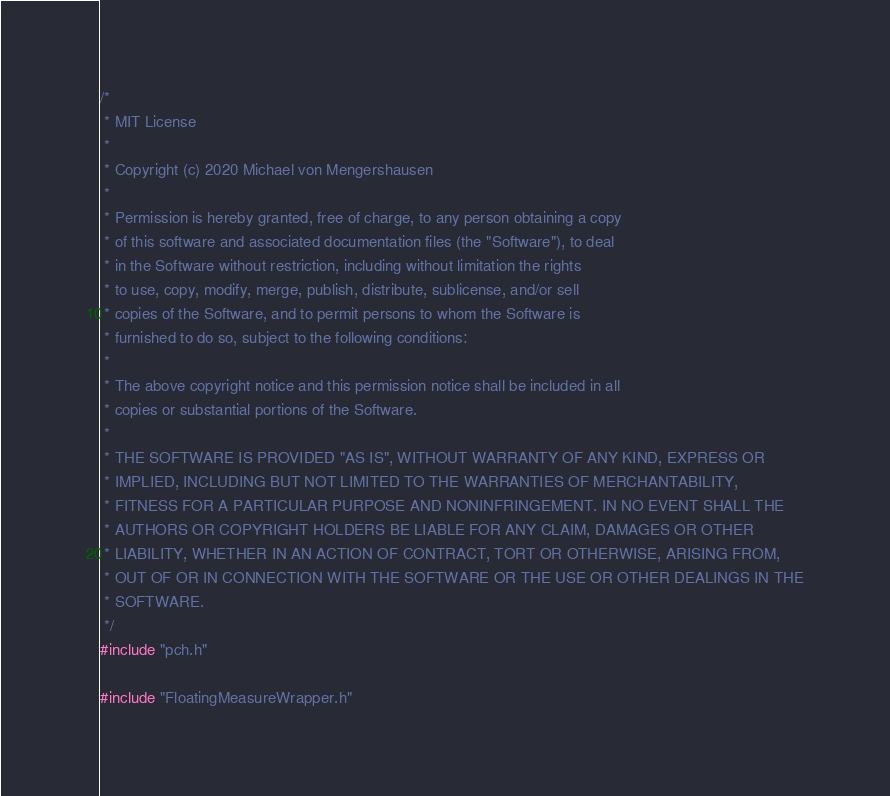Convert code to text. <code><loc_0><loc_0><loc_500><loc_500><_C++_>/*
 * MIT License
 *
 * Copyright (c) 2020 Michael von Mengershausen
 *
 * Permission is hereby granted, free of charge, to any person obtaining a copy
 * of this software and associated documentation files (the "Software"), to deal
 * in the Software without restriction, including without limitation the rights
 * to use, copy, modify, merge, publish, distribute, sublicense, and/or sell
 * copies of the Software, and to permit persons to whom the Software is
 * furnished to do so, subject to the following conditions:
 *
 * The above copyright notice and this permission notice shall be included in all
 * copies or substantial portions of the Software.
 *
 * THE SOFTWARE IS PROVIDED "AS IS", WITHOUT WARRANTY OF ANY KIND, EXPRESS OR
 * IMPLIED, INCLUDING BUT NOT LIMITED TO THE WARRANTIES OF MERCHANTABILITY,
 * FITNESS FOR A PARTICULAR PURPOSE AND NONINFRINGEMENT. IN NO EVENT SHALL THE
 * AUTHORS OR COPYRIGHT HOLDERS BE LIABLE FOR ANY CLAIM, DAMAGES OR OTHER
 * LIABILITY, WHETHER IN AN ACTION OF CONTRACT, TORT OR OTHERWISE, ARISING FROM,
 * OUT OF OR IN CONNECTION WITH THE SOFTWARE OR THE USE OR OTHER DEALINGS IN THE
 * SOFTWARE.
 */
#include "pch.h"

#include "FloatingMeasureWrapper.h"
</code> 